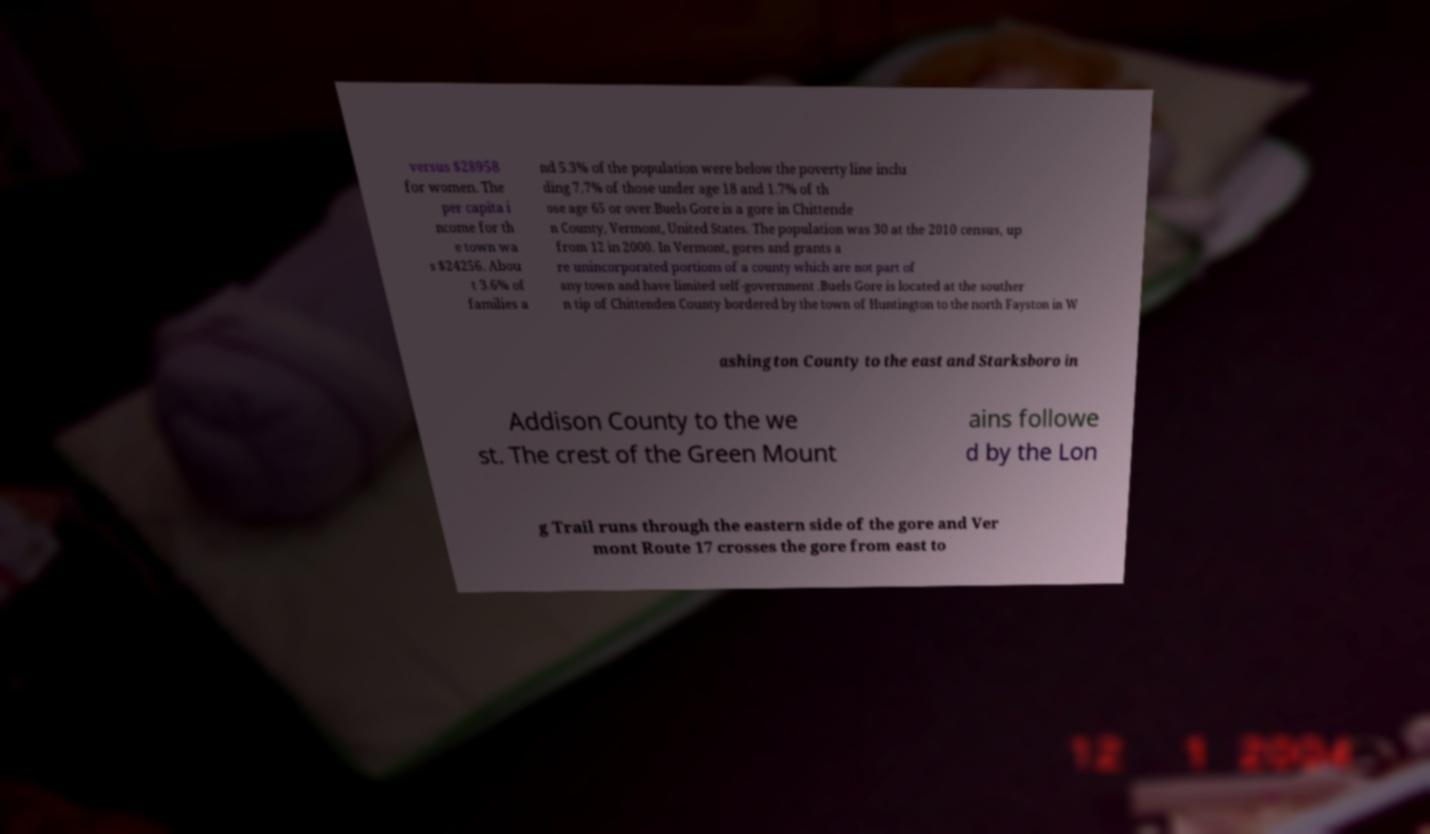Could you assist in decoding the text presented in this image and type it out clearly? versus $28958 for women. The per capita i ncome for th e town wa s $24256. Abou t 3.6% of families a nd 5.3% of the population were below the poverty line inclu ding 7.7% of those under age 18 and 1.7% of th ose age 65 or over.Buels Gore is a gore in Chittende n County, Vermont, United States. The population was 30 at the 2010 census, up from 12 in 2000. In Vermont, gores and grants a re unincorporated portions of a county which are not part of any town and have limited self-government .Buels Gore is located at the souther n tip of Chittenden County bordered by the town of Huntington to the north Fayston in W ashington County to the east and Starksboro in Addison County to the we st. The crest of the Green Mount ains followe d by the Lon g Trail runs through the eastern side of the gore and Ver mont Route 17 crosses the gore from east to 